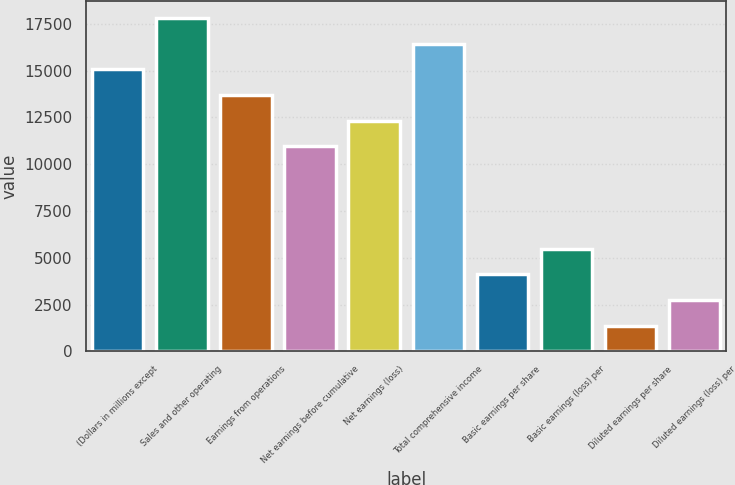Convert chart. <chart><loc_0><loc_0><loc_500><loc_500><bar_chart><fcel>(Dollars in millions except<fcel>Sales and other operating<fcel>Earnings from operations<fcel>Net earnings before cumulative<fcel>Net earnings (loss)<fcel>Total comprehensive income<fcel>Basic earnings per share<fcel>Basic earnings (loss) per<fcel>Diluted earnings per share<fcel>Diluted earnings (loss) per<nl><fcel>15071<fcel>17811.2<fcel>13701<fcel>10960.8<fcel>12330.9<fcel>16441.1<fcel>4110.41<fcel>5480.49<fcel>1370.25<fcel>2740.33<nl></chart> 